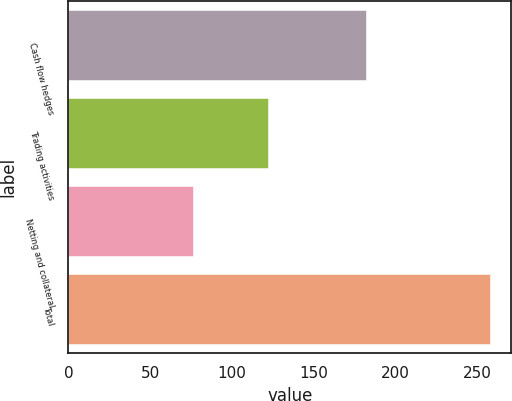<chart> <loc_0><loc_0><loc_500><loc_500><bar_chart><fcel>Cash flow hedges<fcel>Trading activities<fcel>Netting and collateral<fcel>Total<nl><fcel>182<fcel>122<fcel>76<fcel>258<nl></chart> 